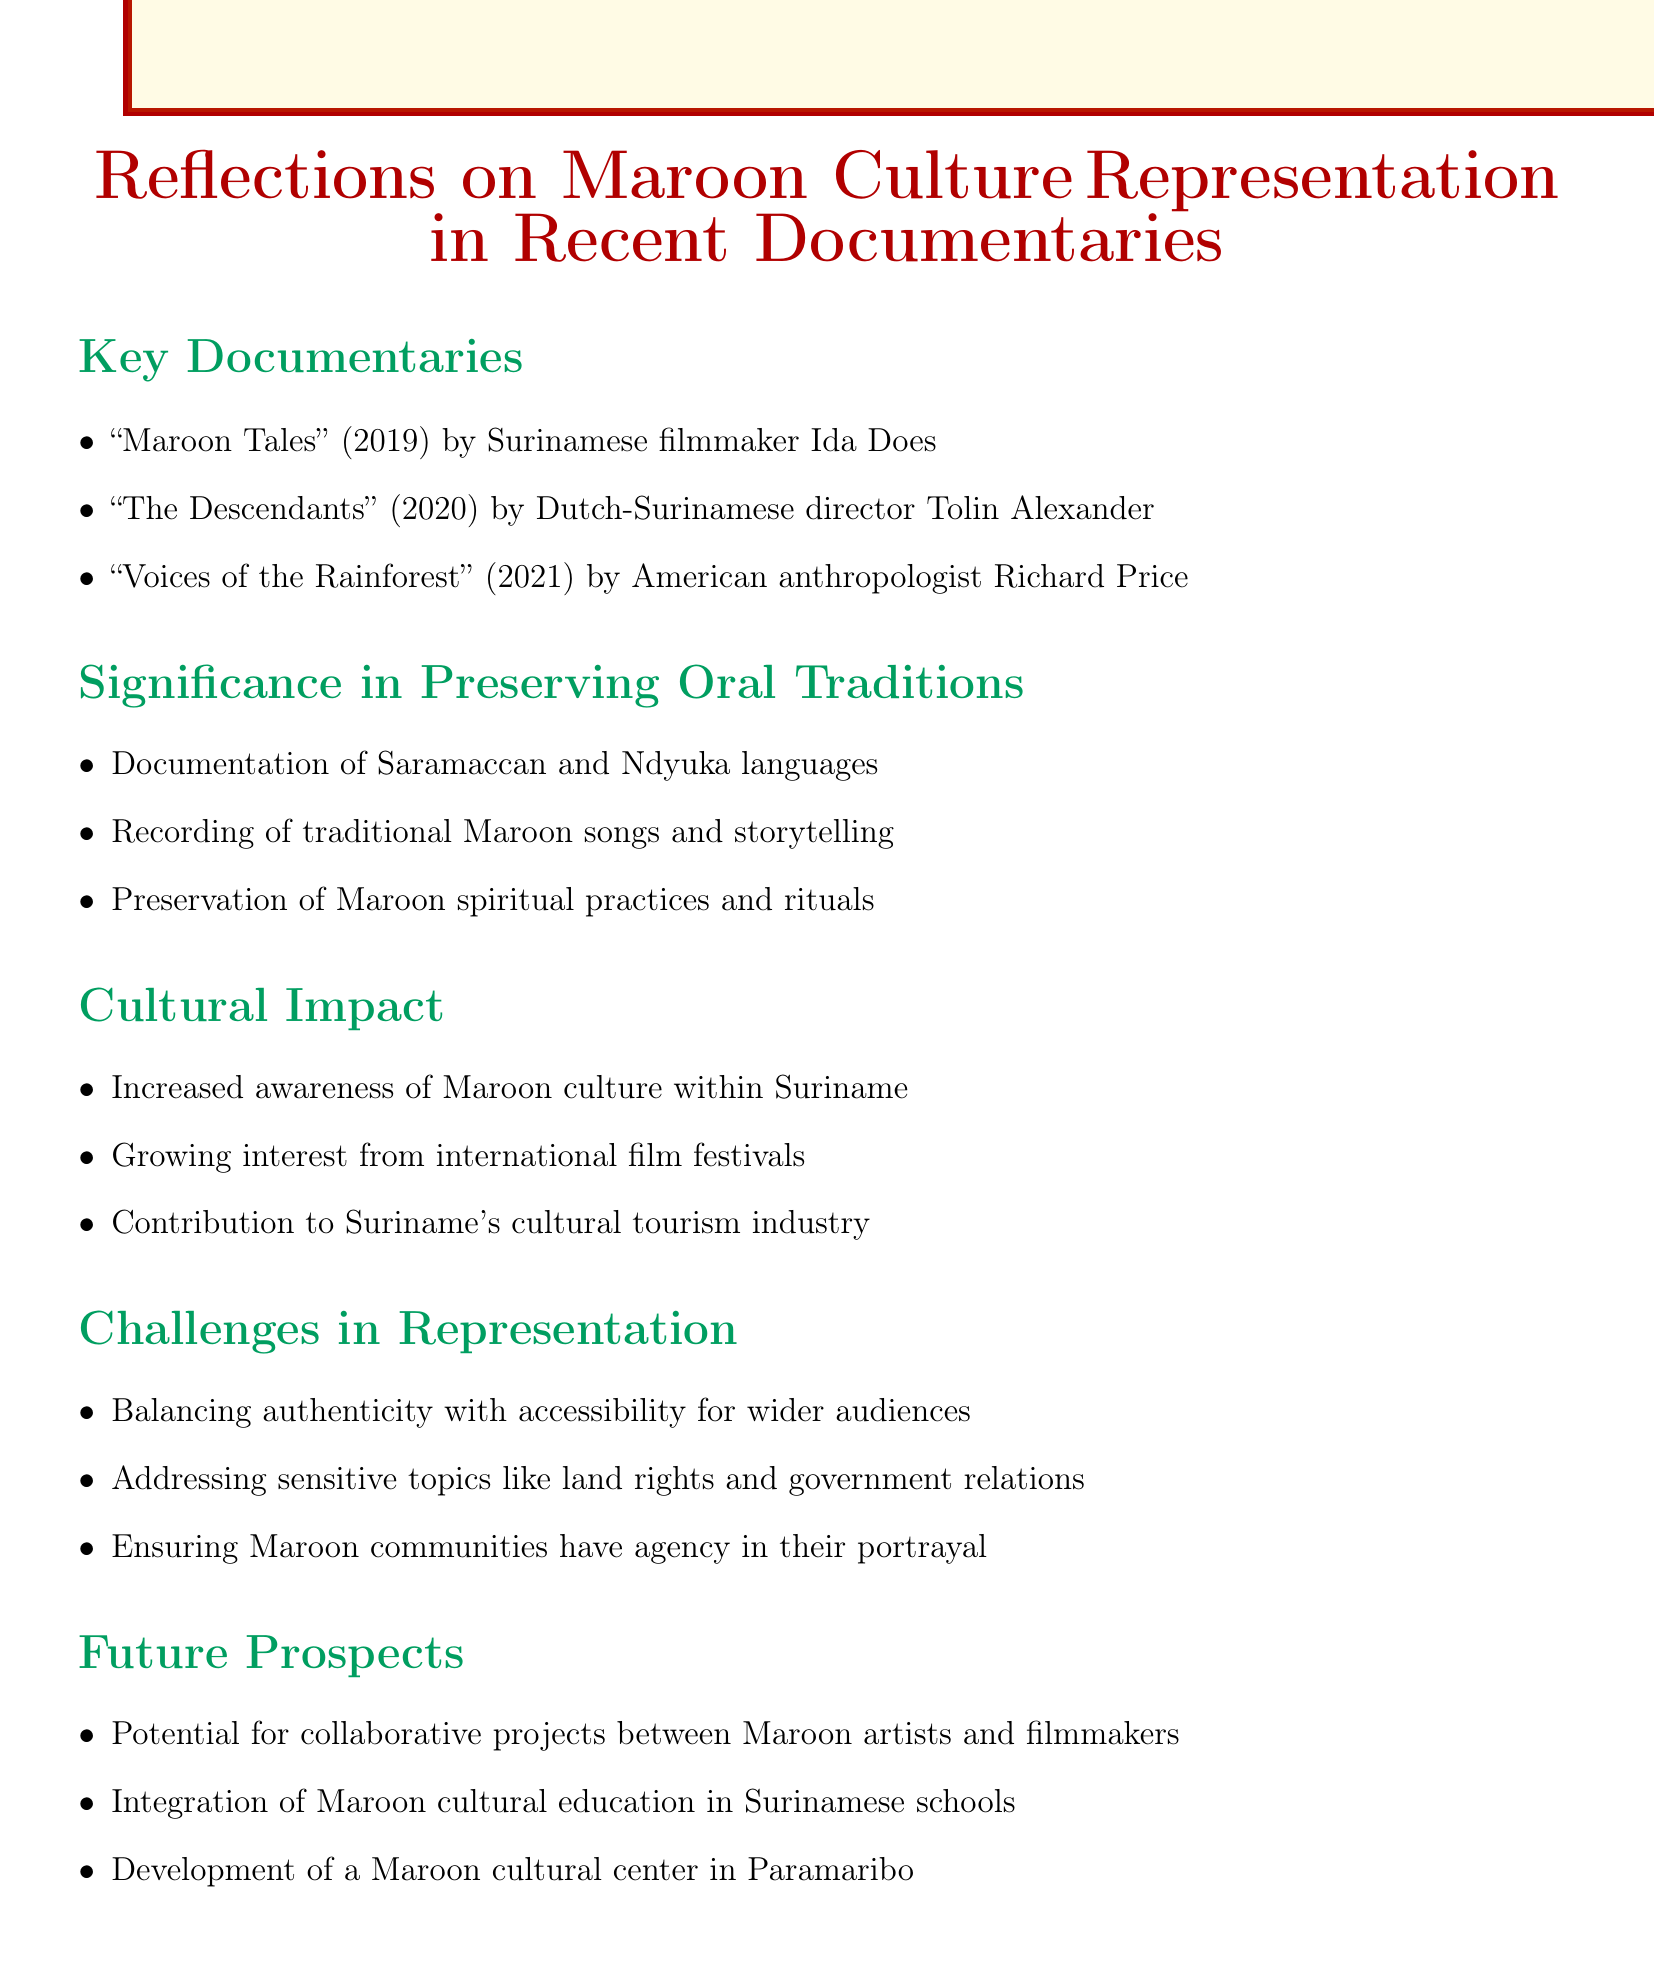what is the title of the 2019 documentary? The title of the 2019 documentary is "Maroon Tales," which is directed by Ida Does.
Answer: "Maroon Tales" who directed "The Descendants"? "The Descendants" is directed by Dutch-Surinamese director Tolin Alexander.
Answer: Tolin Alexander name one traditional practice preserved in the documentaries. One traditional practice preserved in the documentaries is Maroon spiritual practices and rituals.
Answer: Maroon spiritual practices and rituals what is a cultural impact of these documentaries mentioned? One cultural impact mentioned is increased awareness of Maroon culture within Suriname.
Answer: Increased awareness of Maroon culture within Suriname what challenge is related to audience? The challenge related to the audience is balancing authenticity with accessibility for wider audiences.
Answer: Balancing authenticity with accessibility for wider audiences what year was "Voices of the Rainforest" released? "Voices of the Rainforest" was released in 2021.
Answer: 2021 what is a future prospect mentioned for Maroon culture? A future prospect mentioned is the development of a Maroon cultural center in Paramaribo.
Answer: Development of a Maroon cultural center in Paramaribo what type of education is suggested for Surinamese schools? The suggested type of education is the integration of Maroon cultural education in Surinamese schools.
Answer: Maroon cultural education name a language documented in the recent documentaries. One of the languages documented is Saramaccan.
Answer: Saramaccan 